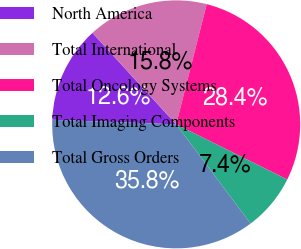Convert chart to OTSL. <chart><loc_0><loc_0><loc_500><loc_500><pie_chart><fcel>North America<fcel>Total International<fcel>Total Oncology Systems<fcel>Total Imaging Components<fcel>Total Gross Orders<nl><fcel>12.61%<fcel>15.76%<fcel>28.38%<fcel>7.42%<fcel>35.83%<nl></chart> 